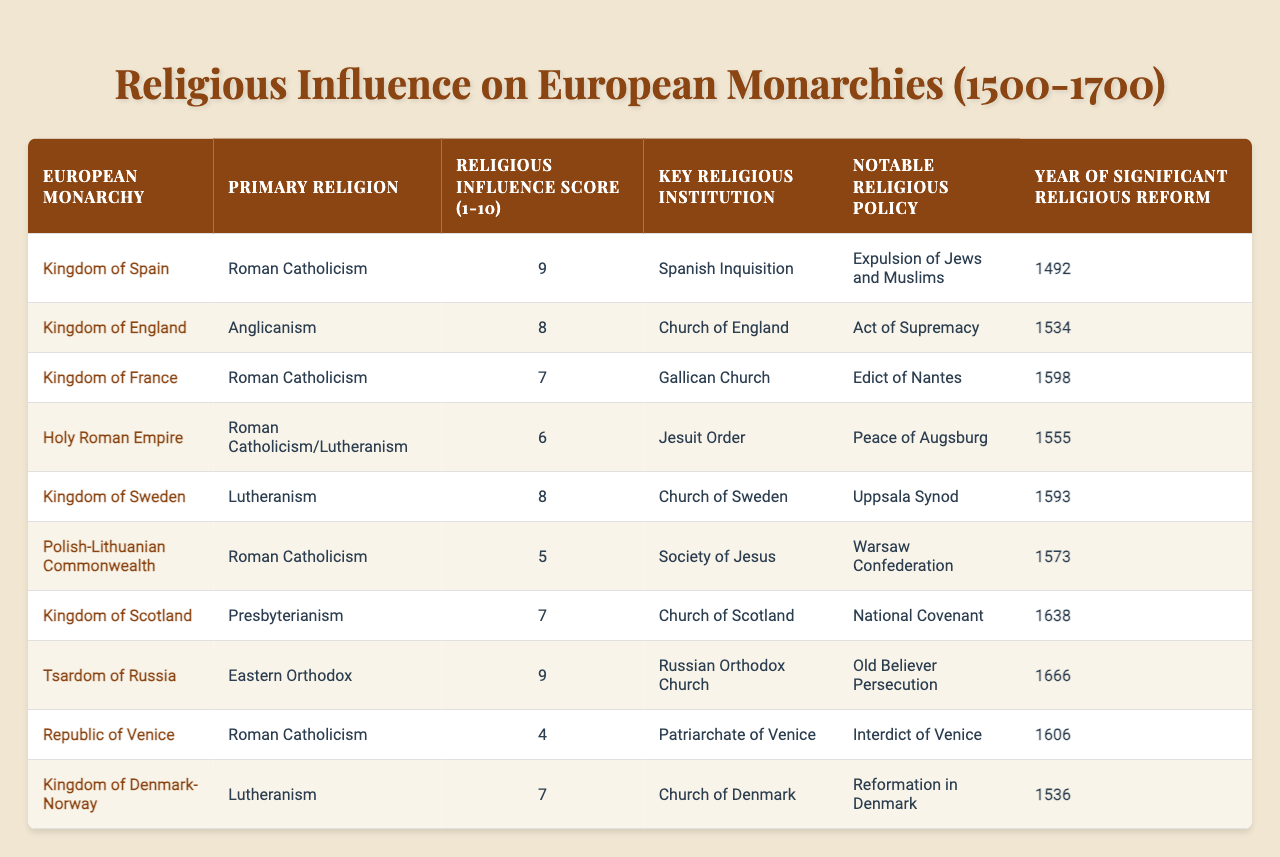What is the primary religion in the Kingdom of Sweden? The table lists the Kingdom of Sweden under the "European Monarchy" column, and it shows that the "Primary Religion" for this kingdom is Lutheranism.
Answer: Lutheranism Which monarchy has the highest religious influence score? By comparing the "Religious Influence Score" values across the table, the Kingdom of Spain has the highest score of 9.
Answer: Kingdom of Spain What notable religious policy did the Holy Roman Empire implement? Looking at the "Notable Religious Policy" column for the Holy Roman Empire, it states that the significant policy implemented is the "Peace of Augsburg."
Answer: Peace of Augsburg Is the "Jesuit Order" a key religious institution in the Polish-Lithuanian Commonwealth? The table shows that the key religious institution for the Polish-Lithuanian Commonwealth is the "Society of Jesus," not the "Jesuit Order." Therefore, the statement is false.
Answer: No Which two monarchies have a religious influence score of 8? Referring to the "Religious Influence Score," both the Kingdom of England and the Kingdom of Sweden have a score of 8.
Answer: Kingdom of England, Kingdom of Sweden What is the year of significant religious reform for the Kingdom of England? The table indicates the "Year of Significant Religious Reform" for the Kingdom of England is 1534, as specified in the corresponding row.
Answer: 1534 List the primary religions of the three monarchies with the lowest religious influence scores. The monarchies with the lowest scores (4 and 5) are the Republic of Venice (4, Roman Catholicism) and the Polish-Lithuanian Commonwealth (5, Roman Catholicism). The third monarchy with a score of 6 is the Holy Roman Empire (mixed religions). So the primary religions are Roman Catholicism and mixed religions.
Answer: Roman Catholicism, mixed religions Which monarchy is associated with the "Old Believer Persecution" and in what year did it occur? The "Old Believer Persecution" is listed under the Tsardom of Russia, with the corresponding year of significant reform being 1666.
Answer: Tsardom of Russia, 1666 Compare the religious influence score between kingdoms with Lutheranism as their primary religion. The table lists the Kingdom of Sweden and the Kingdom of Denmark-Norway both with Lutheranism. The scores are 8 for Sweden and 7 for Denmark-Norway, which shows that Sweden has a higher influence score.
Answer: 8 for Sweden, 7 for Denmark-Norway What is the notable religious policy for the Kingdom of Denmark-Norway? By checking the table, the notable religious policy for the Kingdom of Denmark-Norway is noted as "Reformation in Denmark."
Answer: Reformation in Denmark 